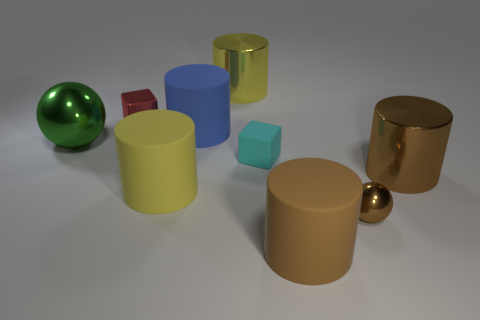Is there anything else that has the same material as the big green sphere?
Ensure brevity in your answer.  Yes. How big is the ball that is to the right of the large green object?
Your answer should be very brief. Small. There is a yellow cylinder that is in front of the large brown metal object; is its size the same as the sphere on the right side of the metallic block?
Make the answer very short. No. How many large yellow objects are the same material as the cyan block?
Give a very brief answer. 1. The small matte block has what color?
Your answer should be very brief. Cyan. There is a small red cube; are there any red metallic objects on the right side of it?
Your response must be concise. No. Do the small matte cube and the tiny metal sphere have the same color?
Your answer should be very brief. No. What number of shiny cylinders have the same color as the large metallic ball?
Give a very brief answer. 0. What size is the brown cylinder that is on the left side of the small brown metallic object that is on the right side of the big yellow rubber cylinder?
Provide a short and direct response. Large. The green object has what shape?
Provide a succinct answer. Sphere. 